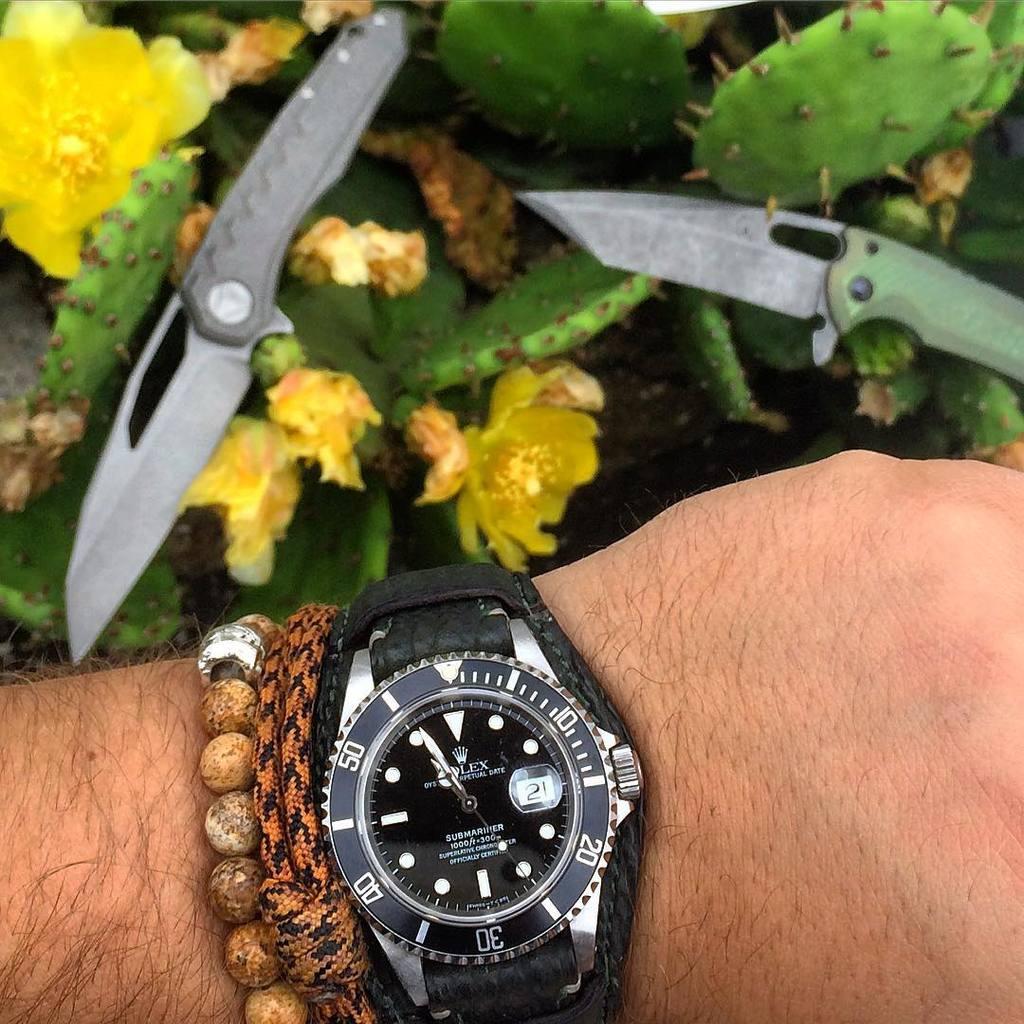What is the brand of watch on this man's wrist?
Your answer should be compact. Rolex. What time is it?
Give a very brief answer. 10:56. 